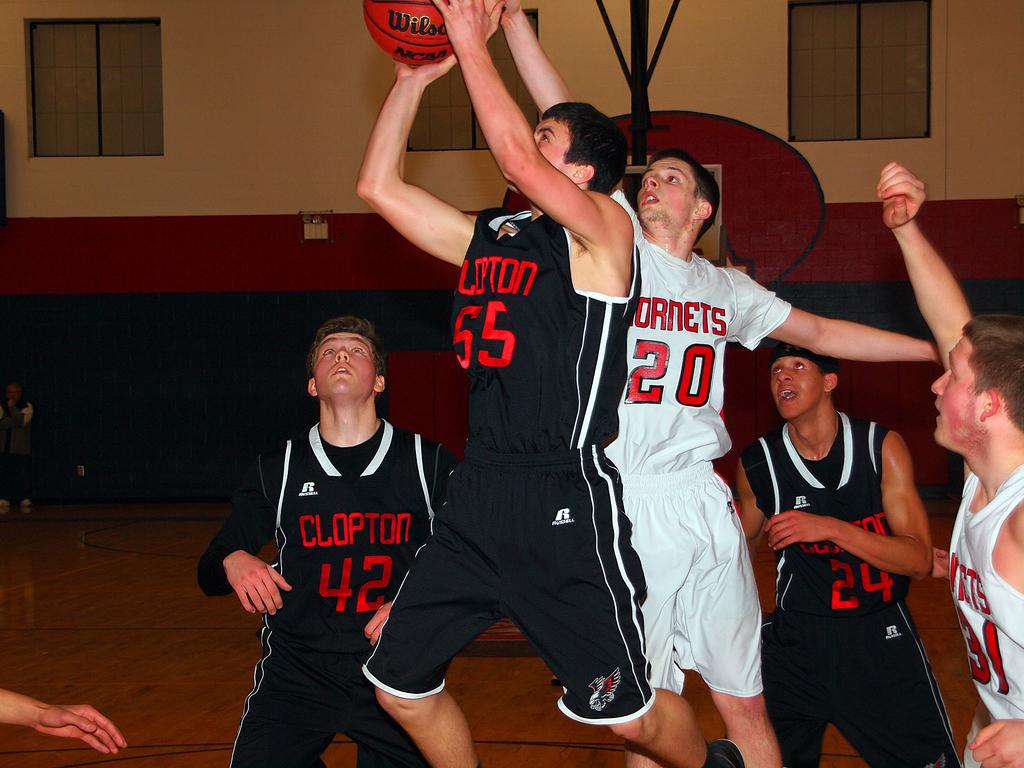<image>
Write a terse but informative summary of the picture. a few players with one wearing the number 20 